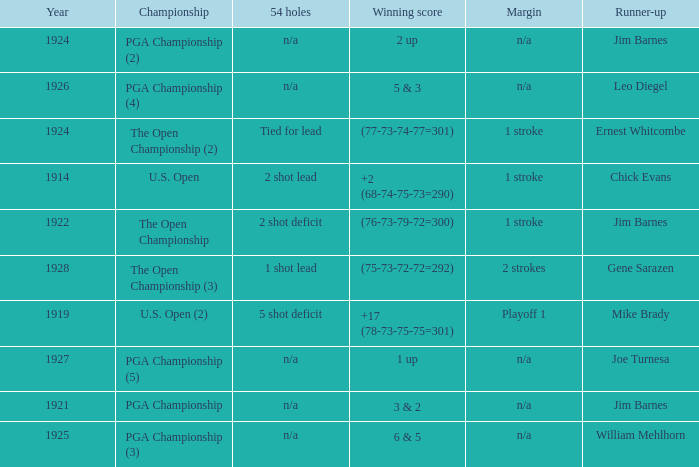HOW MANY YEARS WAS IT FOR THE SCORE (76-73-79-72=300)? 1.0. Can you parse all the data within this table? {'header': ['Year', 'Championship', '54 holes', 'Winning score', 'Margin', 'Runner-up'], 'rows': [['1924', 'PGA Championship (2)', 'n/a', '2 up', 'n/a', 'Jim Barnes'], ['1926', 'PGA Championship (4)', 'n/a', '5 & 3', 'n/a', 'Leo Diegel'], ['1924', 'The Open Championship (2)', 'Tied for lead', '(77-73-74-77=301)', '1 stroke', 'Ernest Whitcombe'], ['1914', 'U.S. Open', '2 shot lead', '+2 (68-74-75-73=290)', '1 stroke', 'Chick Evans'], ['1922', 'The Open Championship', '2 shot deficit', '(76-73-79-72=300)', '1 stroke', 'Jim Barnes'], ['1928', 'The Open Championship (3)', '1 shot lead', '(75-73-72-72=292)', '2 strokes', 'Gene Sarazen'], ['1919', 'U.S. Open (2)', '5 shot deficit', '+17 (78-73-75-75=301)', 'Playoff 1', 'Mike Brady'], ['1927', 'PGA Championship (5)', 'n/a', '1 up', 'n/a', 'Joe Turnesa'], ['1921', 'PGA Championship', 'n/a', '3 & 2', 'n/a', 'Jim Barnes'], ['1925', 'PGA Championship (3)', 'n/a', '6 & 5', 'n/a', 'William Mehlhorn']]} 